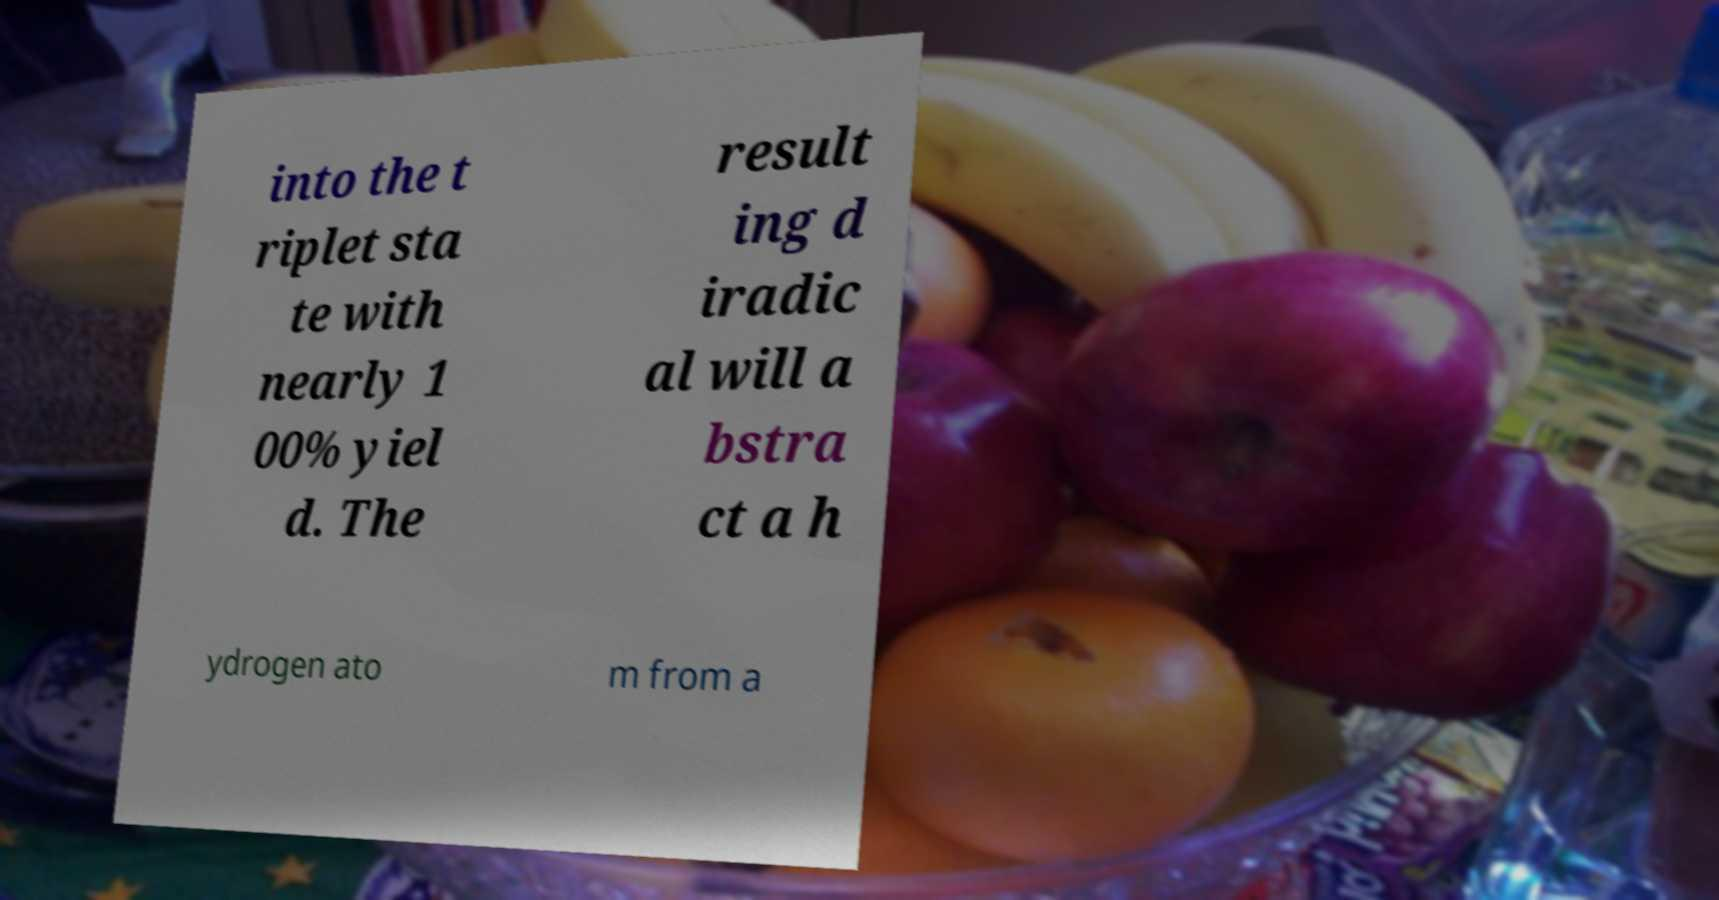There's text embedded in this image that I need extracted. Can you transcribe it verbatim? into the t riplet sta te with nearly 1 00% yiel d. The result ing d iradic al will a bstra ct a h ydrogen ato m from a 